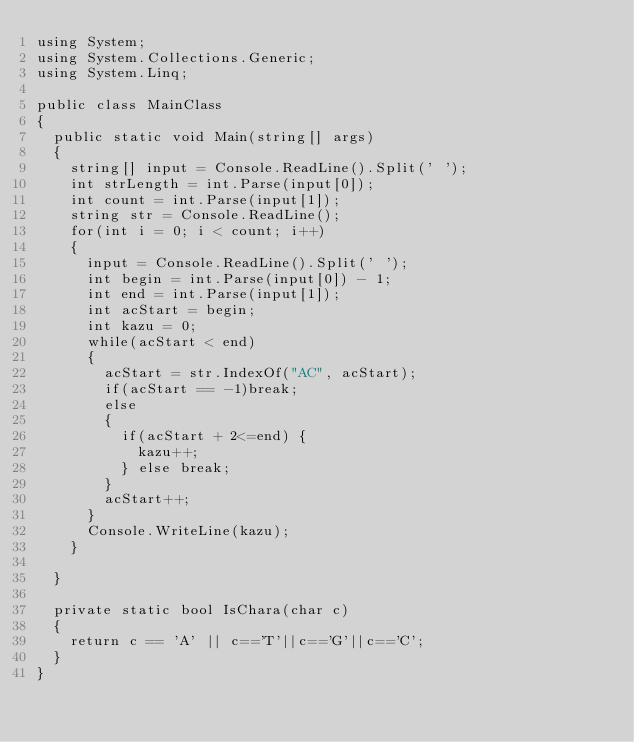Convert code to text. <code><loc_0><loc_0><loc_500><loc_500><_C#_>using System;
using System.Collections.Generic;
using System.Linq;

public class MainClass
{
	public static void Main(string[] args)
	{
		string[] input = Console.ReadLine().Split(' ');
		int strLength = int.Parse(input[0]);
		int count = int.Parse(input[1]);
		string str = Console.ReadLine();
		for(int i = 0; i < count; i++)
		{
			input = Console.ReadLine().Split(' ');
			int begin = int.Parse(input[0]) - 1;
			int end = int.Parse(input[1]);
			int acStart = begin;
			int kazu = 0;
			while(acStart < end)
			{
				acStart = str.IndexOf("AC", acStart);
				if(acStart == -1)break;
				else
				{
					if(acStart + 2<=end) {
						kazu++;
					} else break;
				}
				acStart++;
			}
			Console.WriteLine(kazu);
		}

	}
	
	private static bool IsChara(char c)
	{
		return c == 'A' || c=='T'||c=='G'||c=='C';
	}
}</code> 